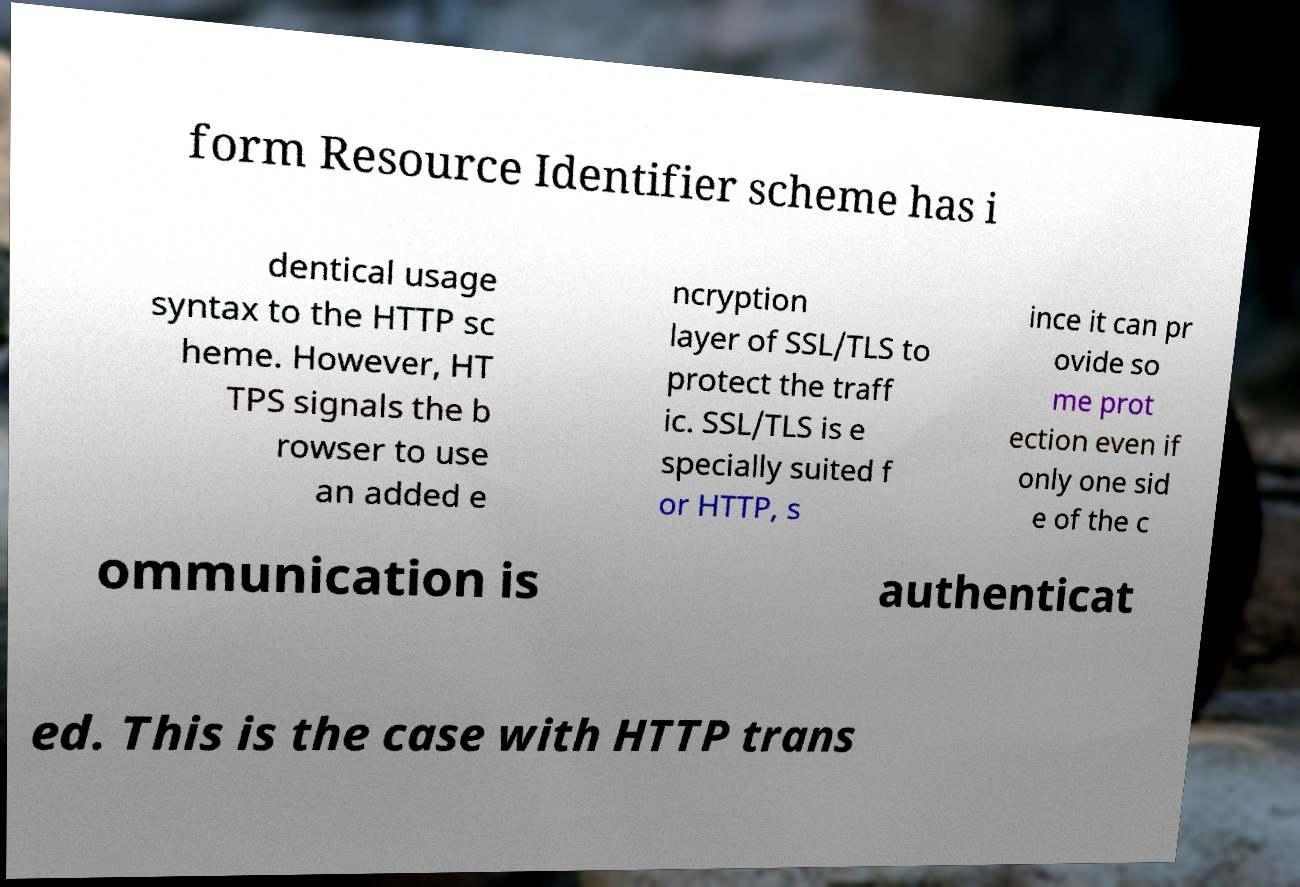There's text embedded in this image that I need extracted. Can you transcribe it verbatim? form Resource Identifier scheme has i dentical usage syntax to the HTTP sc heme. However, HT TPS signals the b rowser to use an added e ncryption layer of SSL/TLS to protect the traff ic. SSL/TLS is e specially suited f or HTTP, s ince it can pr ovide so me prot ection even if only one sid e of the c ommunication is authenticat ed. This is the case with HTTP trans 